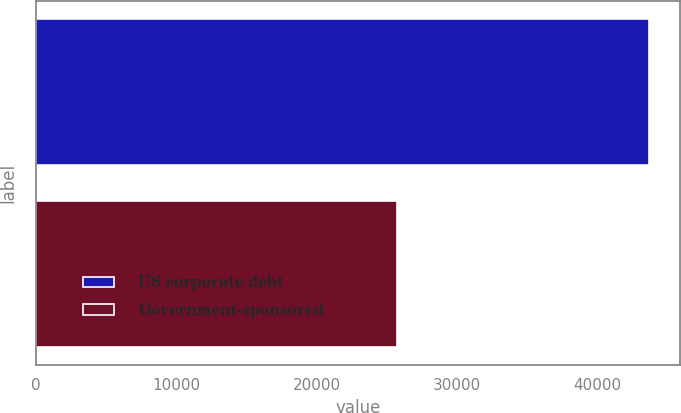Convert chart to OTSL. <chart><loc_0><loc_0><loc_500><loc_500><bar_chart><fcel>US corporate debt<fcel>Government-sponsored<nl><fcel>43695<fcel>25719<nl></chart> 